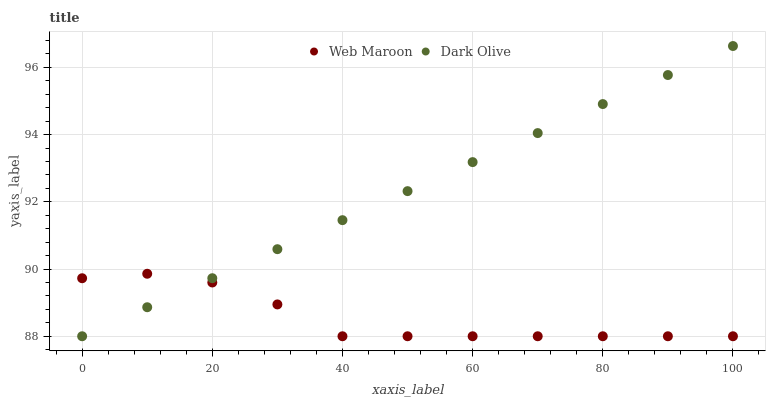Does Web Maroon have the minimum area under the curve?
Answer yes or no. Yes. Does Dark Olive have the maximum area under the curve?
Answer yes or no. Yes. Does Web Maroon have the maximum area under the curve?
Answer yes or no. No. Is Dark Olive the smoothest?
Answer yes or no. Yes. Is Web Maroon the roughest?
Answer yes or no. Yes. Is Web Maroon the smoothest?
Answer yes or no. No. Does Dark Olive have the lowest value?
Answer yes or no. Yes. Does Dark Olive have the highest value?
Answer yes or no. Yes. Does Web Maroon have the highest value?
Answer yes or no. No. Does Web Maroon intersect Dark Olive?
Answer yes or no. Yes. Is Web Maroon less than Dark Olive?
Answer yes or no. No. Is Web Maroon greater than Dark Olive?
Answer yes or no. No. 